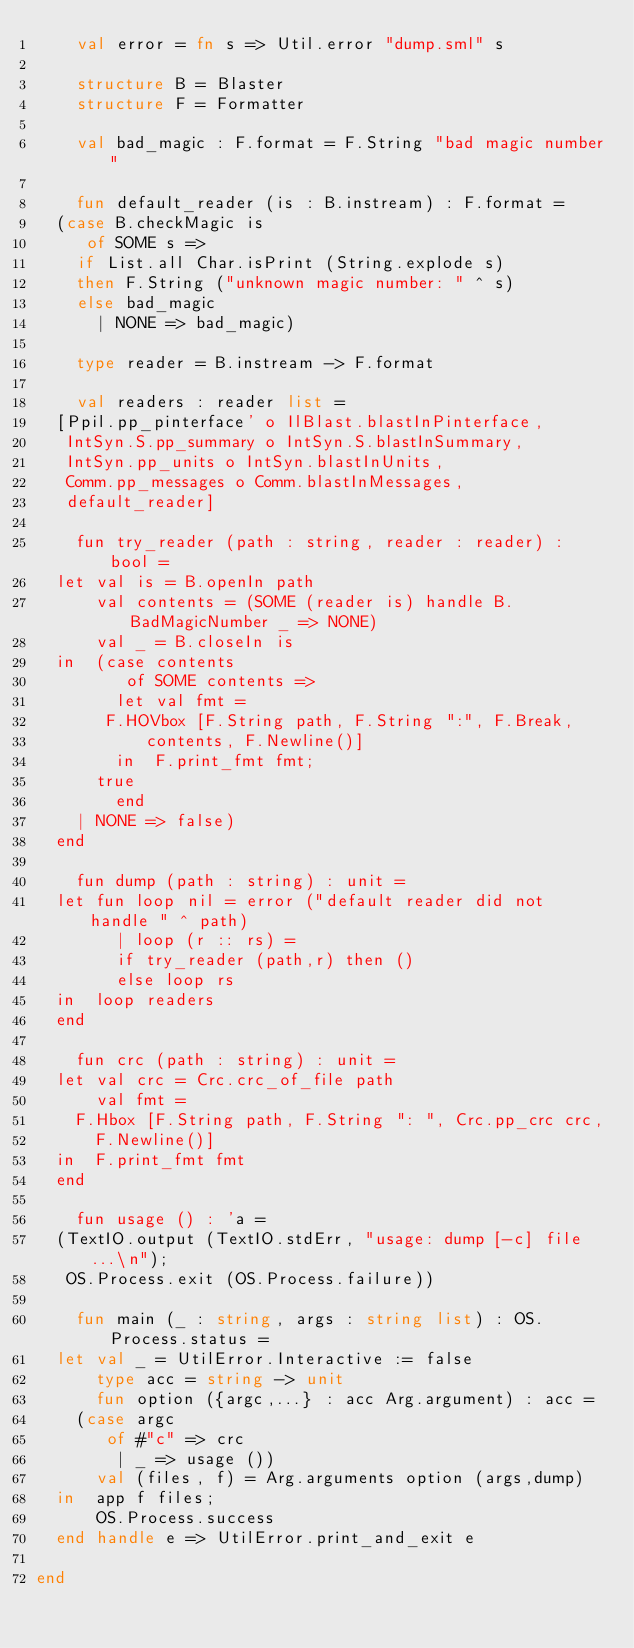<code> <loc_0><loc_0><loc_500><loc_500><_SML_>    val error = fn s => Util.error "dump.sml" s

    structure B = Blaster
    structure F = Formatter

    val bad_magic : F.format = F.String "bad magic number"

    fun default_reader (is : B.instream) : F.format =
	(case B.checkMagic is
	   of SOME s =>
		if List.all Char.isPrint (String.explode s)
		then F.String ("unknown magic number: " ^ s)
		else bad_magic
	    | NONE => bad_magic)

    type reader = B.instream -> F.format

    val readers : reader list =
	[Ppil.pp_pinterface' o IlBlast.blastInPinterface,
	 IntSyn.S.pp_summary o IntSyn.S.blastInSummary,
	 IntSyn.pp_units o IntSyn.blastInUnits,
	 Comm.pp_messages o Comm.blastInMessages,
	 default_reader]

    fun try_reader (path : string, reader : reader) : bool =
	let val is = B.openIn path
	    val contents = (SOME (reader is) handle B.BadMagicNumber _ => NONE)
	    val _ = B.closeIn is
	in  (case contents
	       of SOME contents =>
		    let val fmt =
			 F.HOVbox [F.String path, F.String ":", F.Break,
				   contents, F.Newline()]
		    in  F.print_fmt fmt;
			true
		    end
		| NONE => false)
	end

    fun dump (path : string) : unit =
	let fun loop nil = error ("default reader did not handle " ^ path)
	      | loop (r :: rs) =
		    if try_reader (path,r) then ()
		    else loop rs
	in  loop readers
	end

    fun crc (path : string) : unit =
	let val crc = Crc.crc_of_file path
	    val fmt =
		F.Hbox [F.String path, F.String ": ", Crc.pp_crc crc,
			F.Newline()]
	in  F.print_fmt fmt
	end

    fun usage () : 'a =
	(TextIO.output (TextIO.stdErr, "usage: dump [-c] file ...\n");
	 OS.Process.exit (OS.Process.failure))

    fun main (_ : string, args : string list) : OS.Process.status =
	let val _ = UtilError.Interactive := false
	    type acc = string -> unit
	    fun option ({argc,...} : acc Arg.argument) : acc =
		(case argc
		   of #"c" => crc
		    | _ => usage ())
	    val (files, f) = Arg.arguments option (args,dump)
	in  app f files;
	    OS.Process.success
	end handle e => UtilError.print_and_exit e

end
</code> 